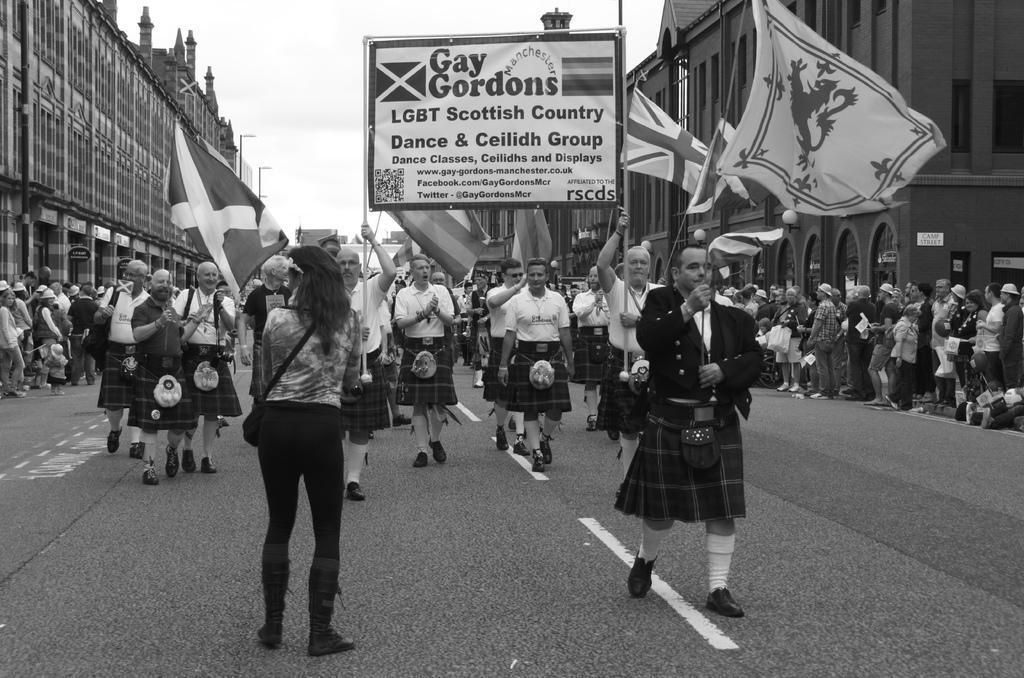Describe this image in one or two sentences. In this image we can see black and white picture of a group of persons standing on the ground. Some persons are holding flags in their hands. Two persons are holding a board with some text on it. In the background, we can see a group of buildings with windows and towers and the sky. 